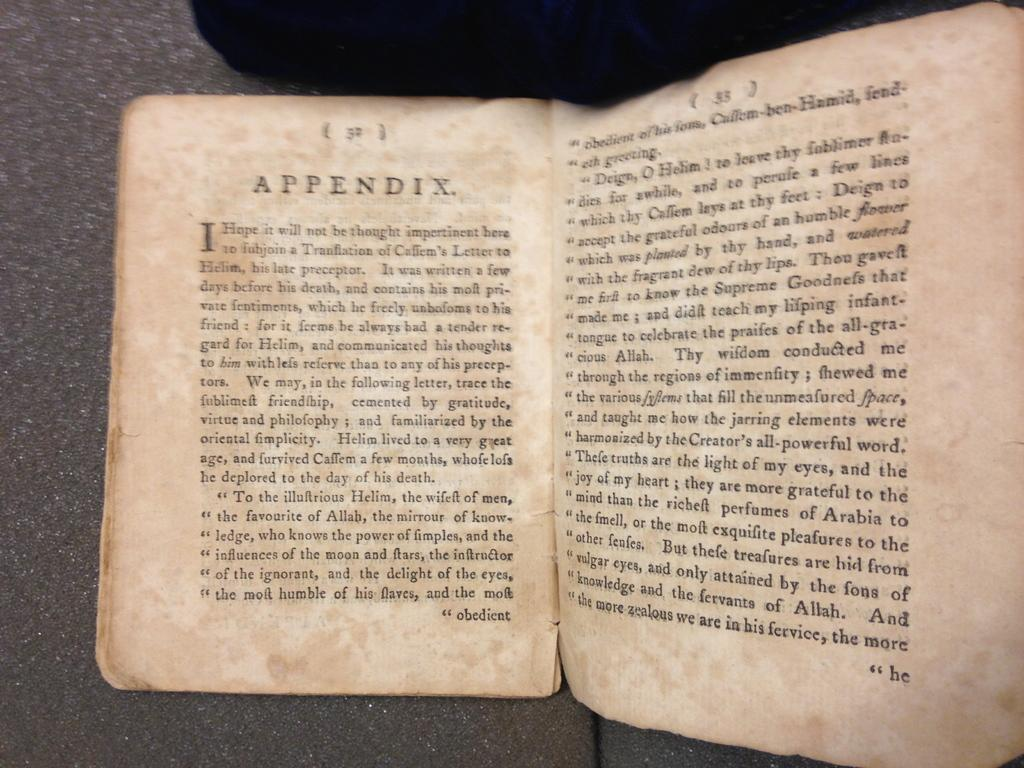<image>
Write a terse but informative summary of the picture. An old weathered book is opened to the Appendix page 